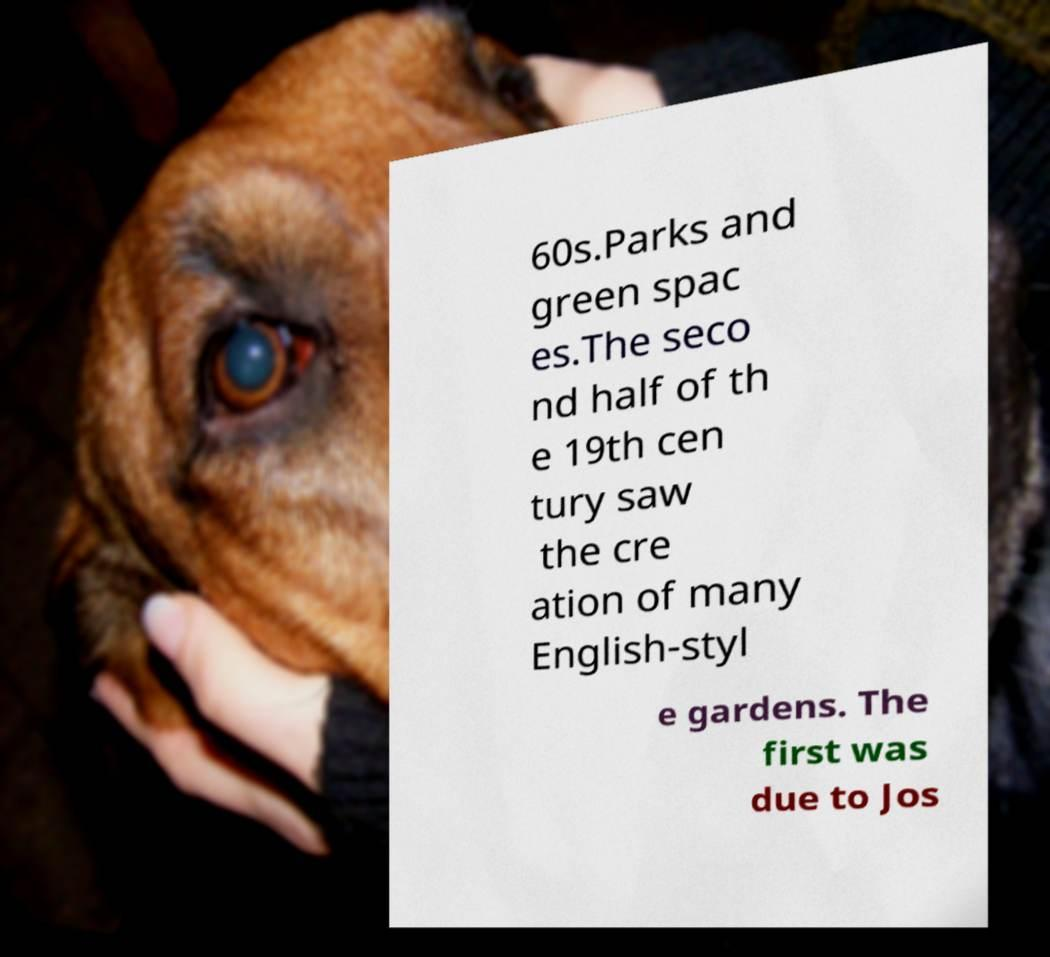Could you assist in decoding the text presented in this image and type it out clearly? 60s.Parks and green spac es.The seco nd half of th e 19th cen tury saw the cre ation of many English-styl e gardens. The first was due to Jos 